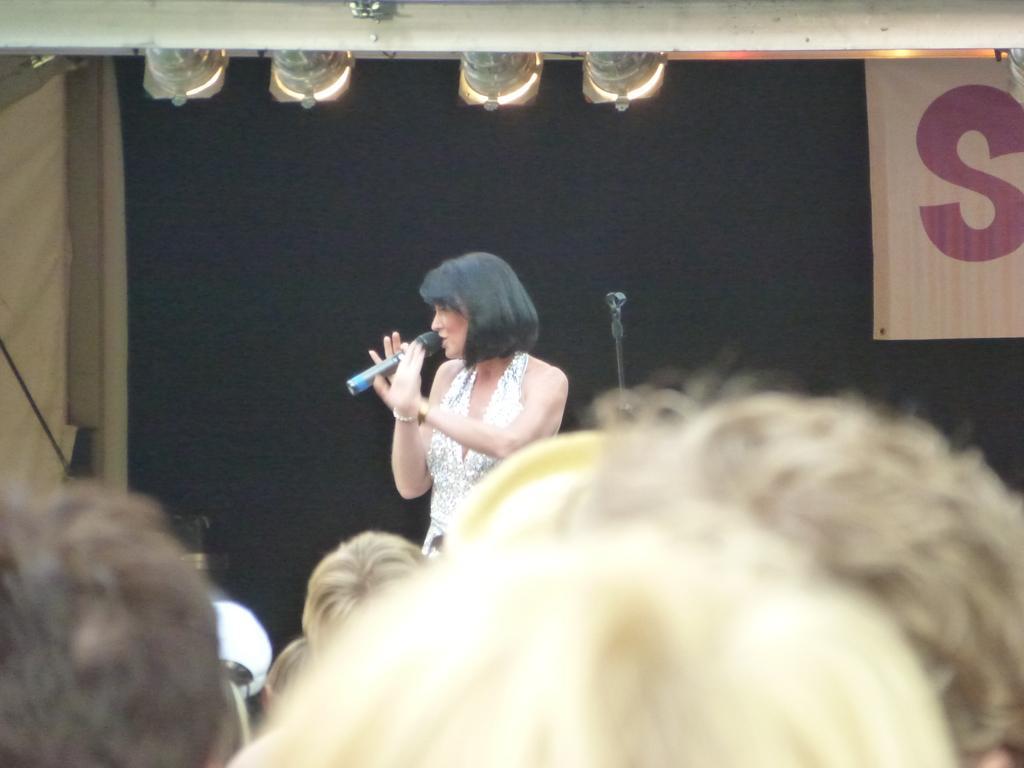How would you summarize this image in a sentence or two? In this image we can see few people, a person is standing and holding a mic and there is a stand beside the person, there are lights on the top of the image and there is a banner on the right side of the image and a dark background. 